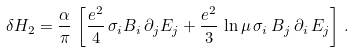<formula> <loc_0><loc_0><loc_500><loc_500>\delta H _ { 2 } = \frac { \alpha } { \pi } \, \left [ \frac { e ^ { 2 } } { 4 } \, \sigma _ { i } B _ { i } \, \partial _ { j } E _ { j } + \frac { e ^ { 2 } } { 3 } \, \ln \mu \, \sigma _ { i } \, B _ { j } \, \partial _ { i } \, E _ { j } \right ] \, .</formula> 